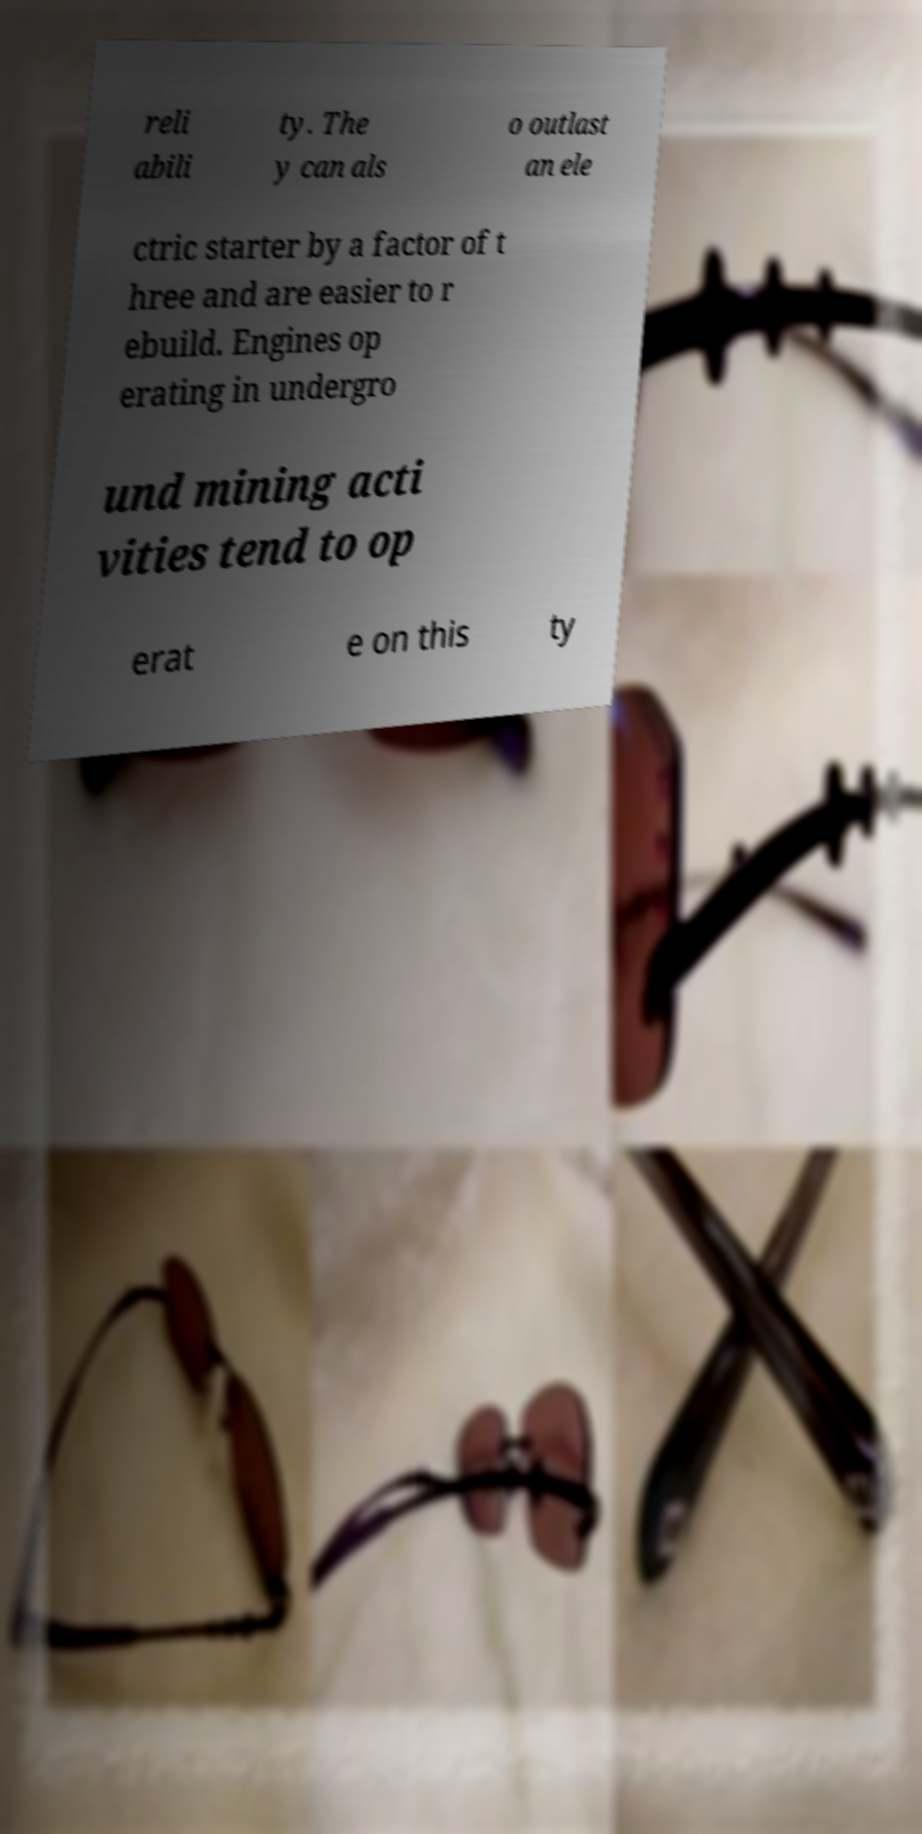There's text embedded in this image that I need extracted. Can you transcribe it verbatim? reli abili ty. The y can als o outlast an ele ctric starter by a factor of t hree and are easier to r ebuild. Engines op erating in undergro und mining acti vities tend to op erat e on this ty 